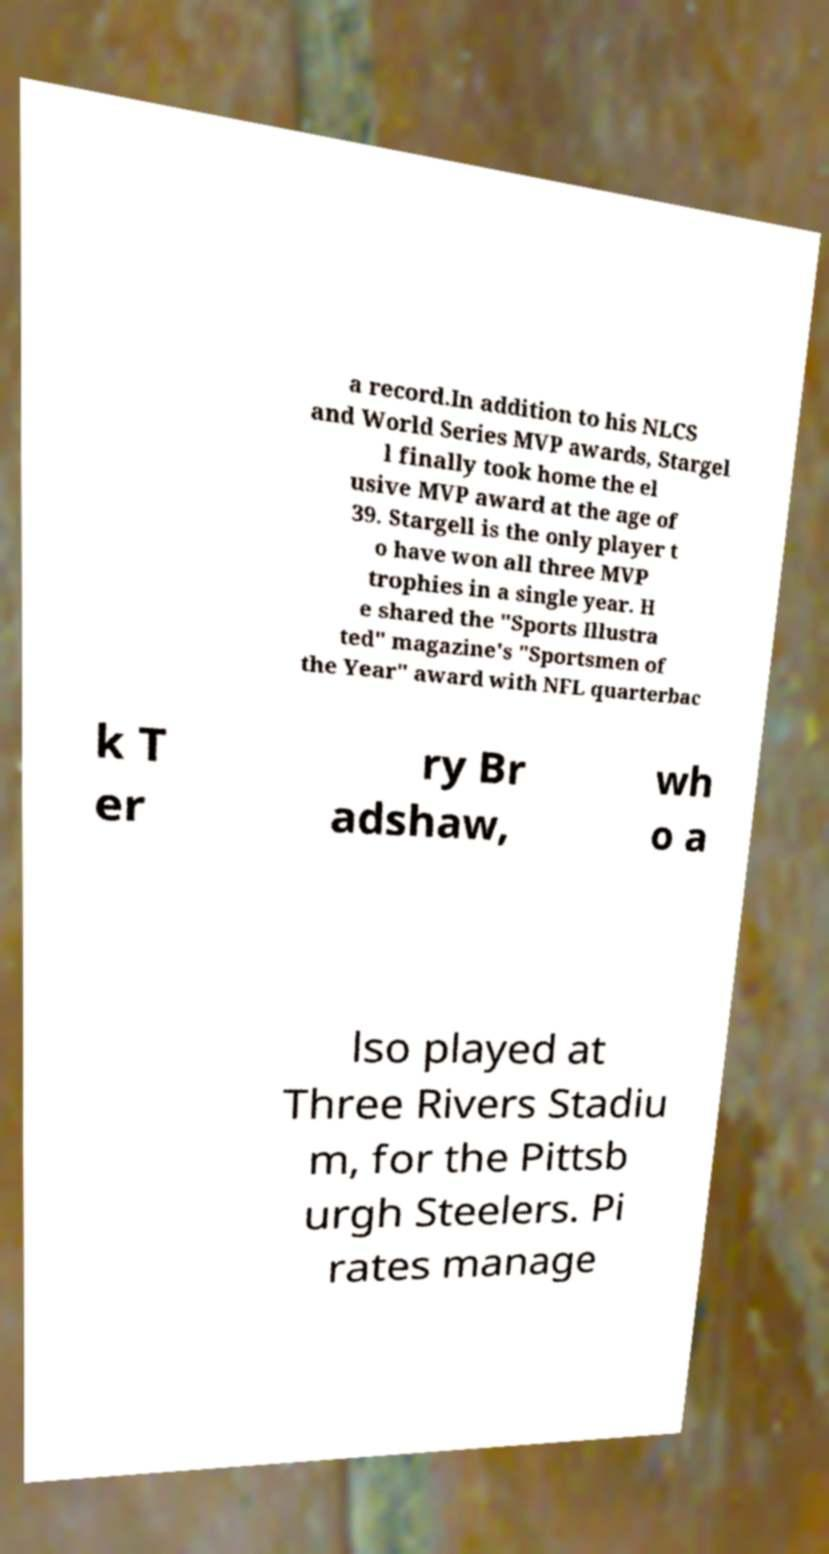Please read and relay the text visible in this image. What does it say? a record.In addition to his NLCS and World Series MVP awards, Stargel l finally took home the el usive MVP award at the age of 39. Stargell is the only player t o have won all three MVP trophies in a single year. H e shared the "Sports Illustra ted" magazine's "Sportsmen of the Year" award with NFL quarterbac k T er ry Br adshaw, wh o a lso played at Three Rivers Stadiu m, for the Pittsb urgh Steelers. Pi rates manage 